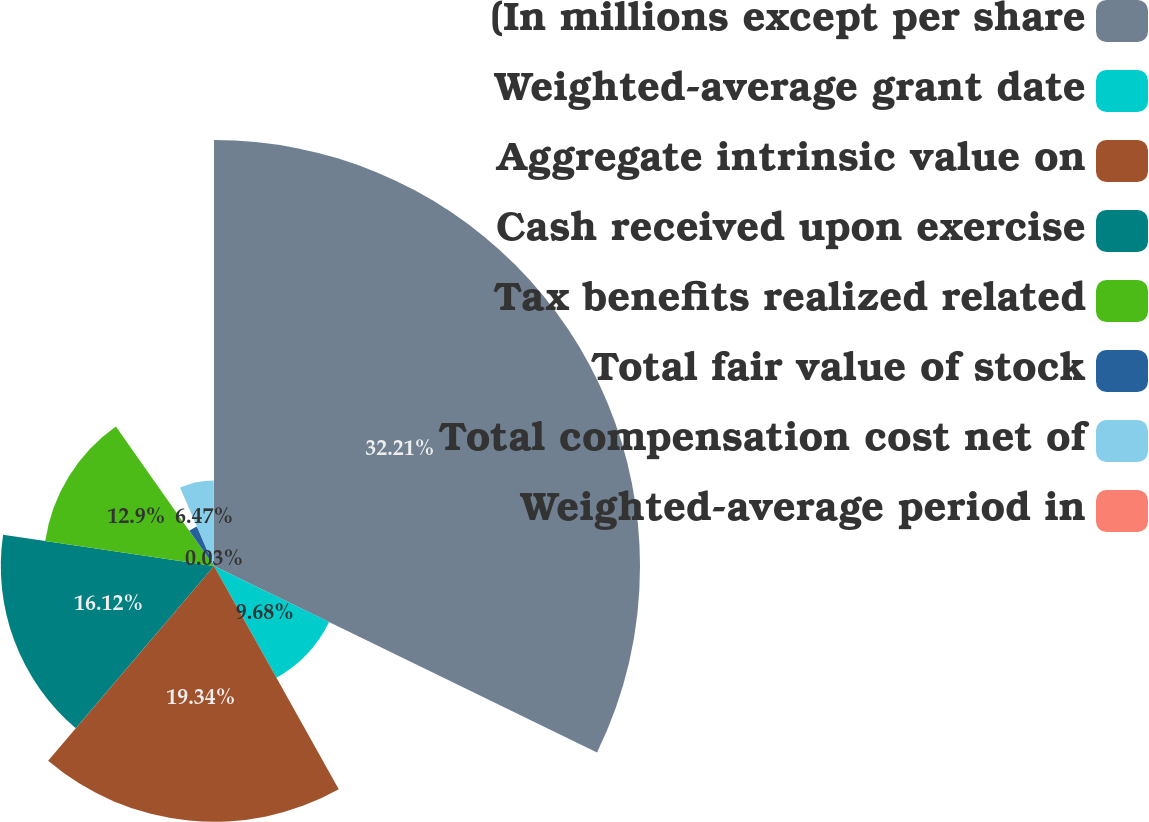<chart> <loc_0><loc_0><loc_500><loc_500><pie_chart><fcel>(In millions except per share<fcel>Weighted-average grant date<fcel>Aggregate intrinsic value on<fcel>Cash received upon exercise<fcel>Tax benefits realized related<fcel>Total fair value of stock<fcel>Total compensation cost net of<fcel>Weighted-average period in<nl><fcel>32.21%<fcel>9.68%<fcel>19.34%<fcel>16.12%<fcel>12.9%<fcel>3.25%<fcel>6.47%<fcel>0.03%<nl></chart> 